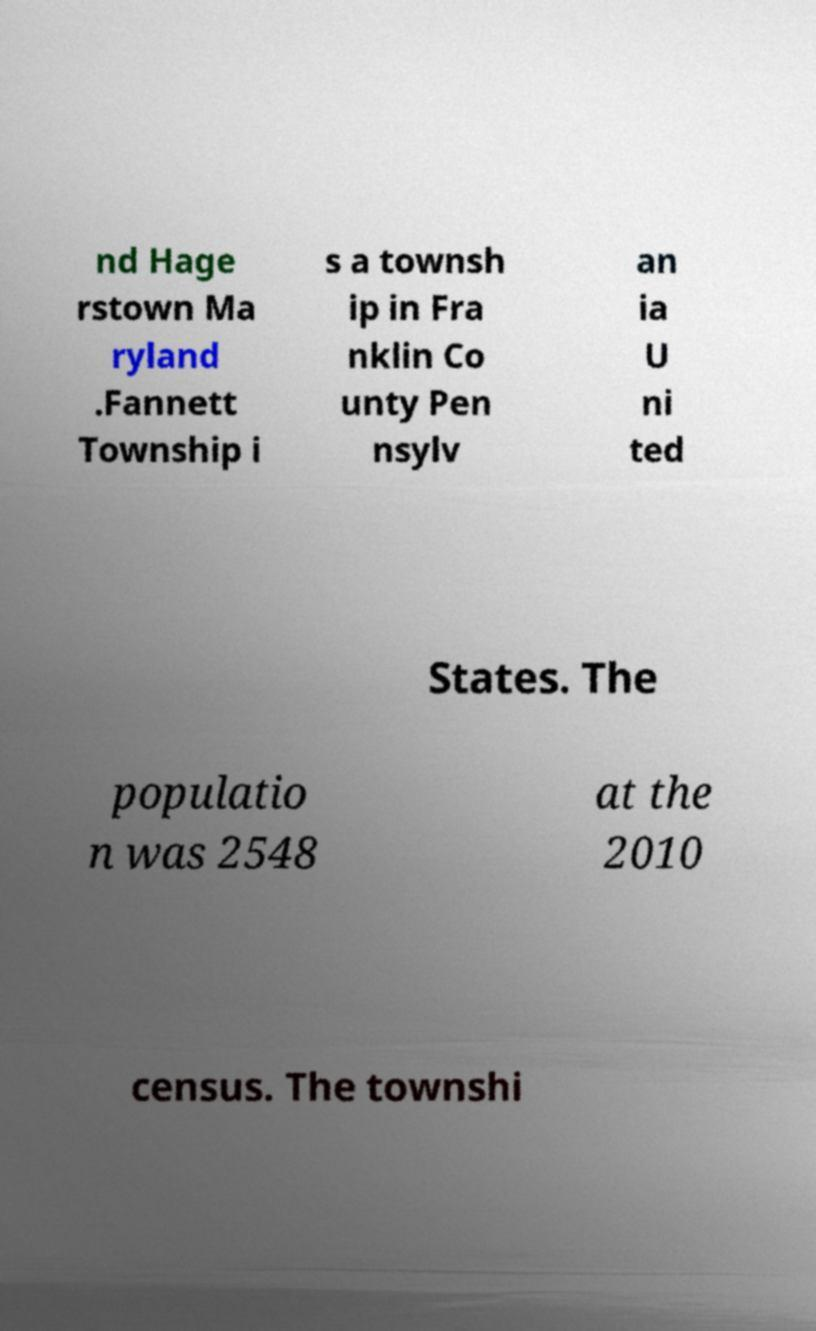Please identify and transcribe the text found in this image. nd Hage rstown Ma ryland .Fannett Township i s a townsh ip in Fra nklin Co unty Pen nsylv an ia U ni ted States. The populatio n was 2548 at the 2010 census. The townshi 